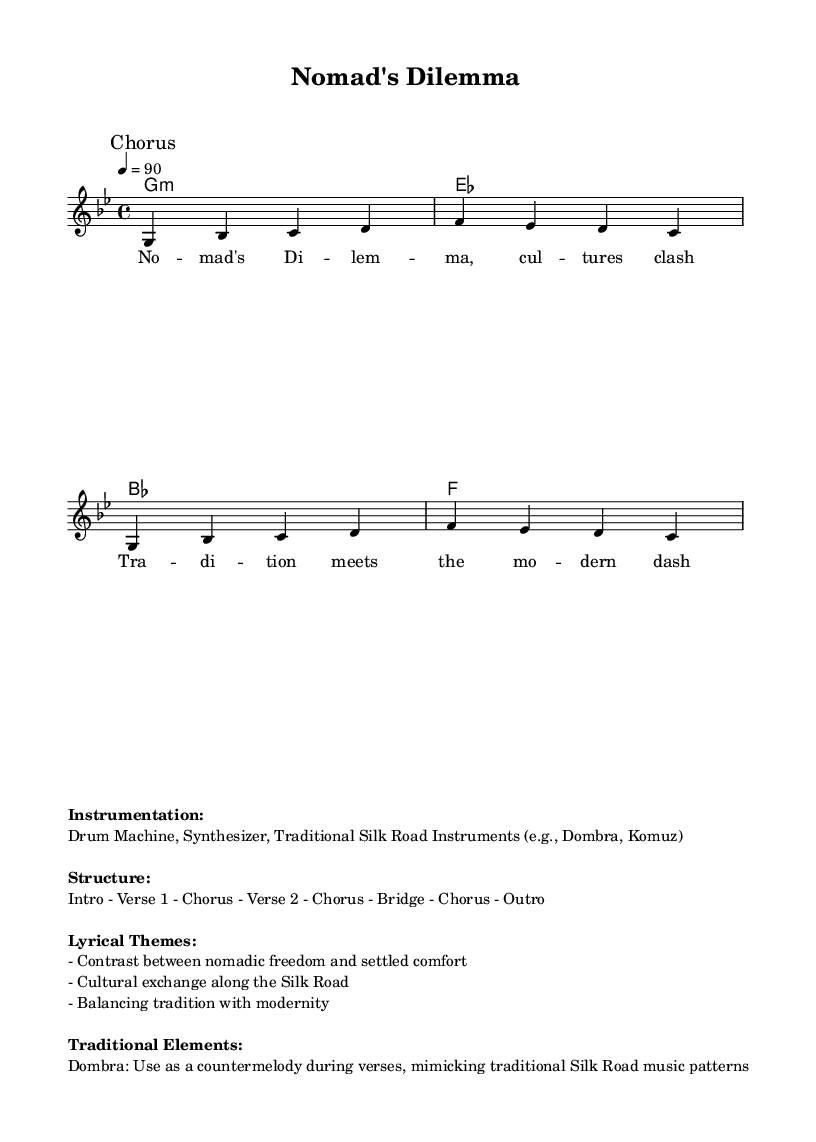What is the key signature of this music? The key signature is G minor, indicated by the 'g' in the global settings. G minor has two flats.
Answer: G minor What is the time signature of this music? The time signature is 4/4, which is shown in the global settings as \time 4/4.
Answer: 4/4 What is the tempo marking of this music? The tempo marking is set to 90 beats per minute, as indicated by "4 = 90".
Answer: 90 What traditional instrument is used as a countermelody during the verses? The Dombra is mentioned in the traditional elements section as being used to mimic traditional Silk Road music patterns.
Answer: Dombra How many sections are listed in the structure of the piece? The structure includes eight sections: Intro, Verse 1, Chorus, Verse 2, Chorus, Bridge, Chorus, Outro. Counting these gives us a total of eight sections.
Answer: Eight What lyrical theme contrasts nomadic freedom with settled comfort in the song? The lyrics explore the theme of 'Contrast between nomadic freedom and settled comfort' as stated in the lyrical themes section.
Answer: Nomadic freedom vs settled comfort 